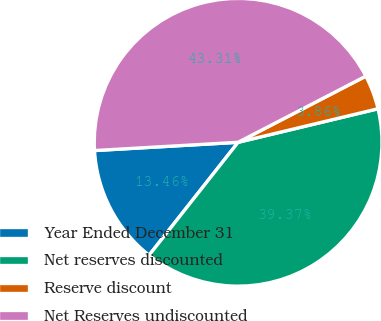Convert chart. <chart><loc_0><loc_0><loc_500><loc_500><pie_chart><fcel>Year Ended December 31<fcel>Net reserves discounted<fcel>Reserve discount<fcel>Net Reserves undiscounted<nl><fcel>13.46%<fcel>39.37%<fcel>3.86%<fcel>43.31%<nl></chart> 